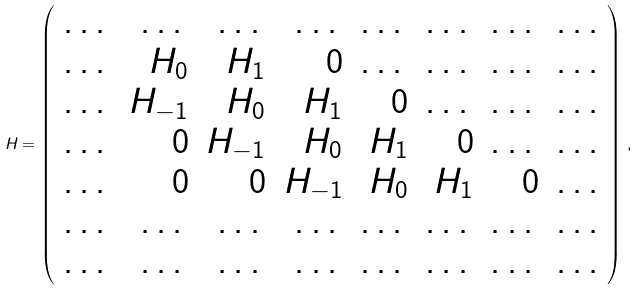<formula> <loc_0><loc_0><loc_500><loc_500>H = \left ( \begin{array} [ h ] { r r r r r r r r } \dots & \dots & \dots & \dots & \dots & \dots & \dots & \dots \\ \dots & H _ { 0 } & H _ { 1 } & 0 & \dots & \dots & \dots & \dots \\ \dots & H _ { - 1 } & H _ { 0 } & H _ { 1 } & 0 & \dots & \dots & \dots \\ \dots & 0 & H _ { - 1 } & H _ { 0 } & H _ { 1 } & 0 & \dots & \dots \\ \dots & 0 & 0 & H _ { - 1 } & H _ { 0 } & H _ { 1 } & 0 & \dots \\ \dots & \dots & \dots & \dots & \dots & \dots & \dots & \dots \\ \dots & \dots & \dots & \dots & \dots & \dots & \dots & \dots \\ \end{array} \right ) { \, } ,</formula> 